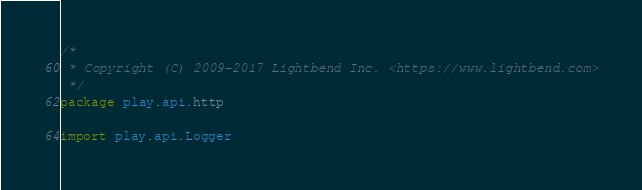Convert code to text. <code><loc_0><loc_0><loc_500><loc_500><_Scala_>/*
 * Copyright (C) 2009-2017 Lightbend Inc. <https://www.lightbend.com>
 */
package play.api.http

import play.api.Logger</code> 